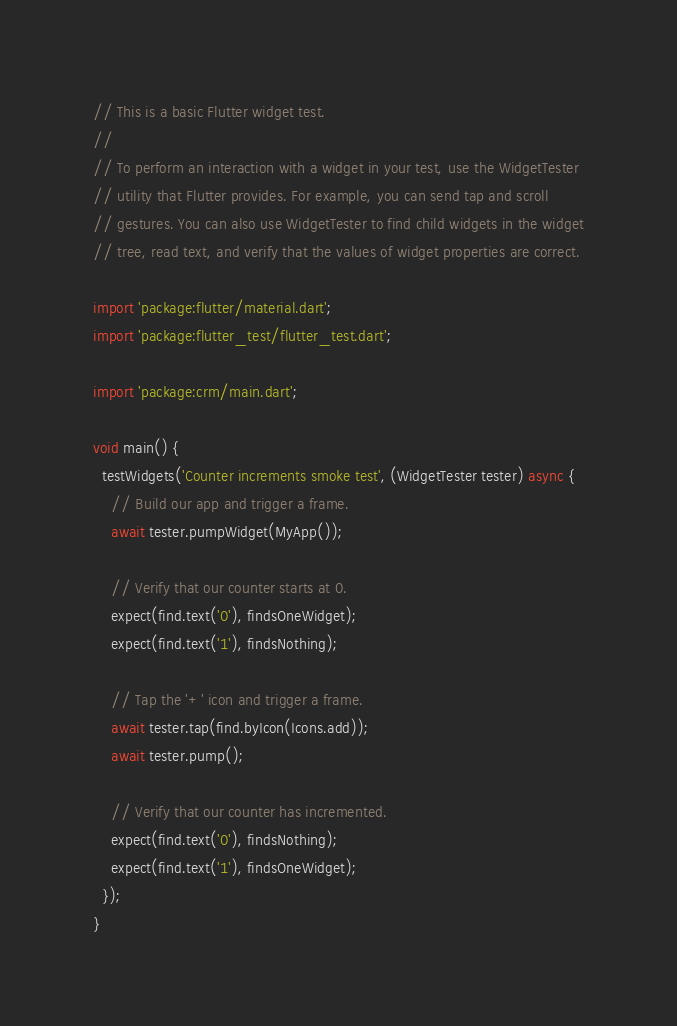<code> <loc_0><loc_0><loc_500><loc_500><_Dart_>// This is a basic Flutter widget test.
//
// To perform an interaction with a widget in your test, use the WidgetTester
// utility that Flutter provides. For example, you can send tap and scroll
// gestures. You can also use WidgetTester to find child widgets in the widget
// tree, read text, and verify that the values of widget properties are correct.

import 'package:flutter/material.dart';
import 'package:flutter_test/flutter_test.dart';

import 'package:crm/main.dart';

void main() {
  testWidgets('Counter increments smoke test', (WidgetTester tester) async {
    // Build our app and trigger a frame.
    await tester.pumpWidget(MyApp());

    // Verify that our counter starts at 0.
    expect(find.text('0'), findsOneWidget);
    expect(find.text('1'), findsNothing);

    // Tap the '+' icon and trigger a frame.
    await tester.tap(find.byIcon(Icons.add));
    await tester.pump();

    // Verify that our counter has incremented.
    expect(find.text('0'), findsNothing);
    expect(find.text('1'), findsOneWidget);
  });
}
</code> 